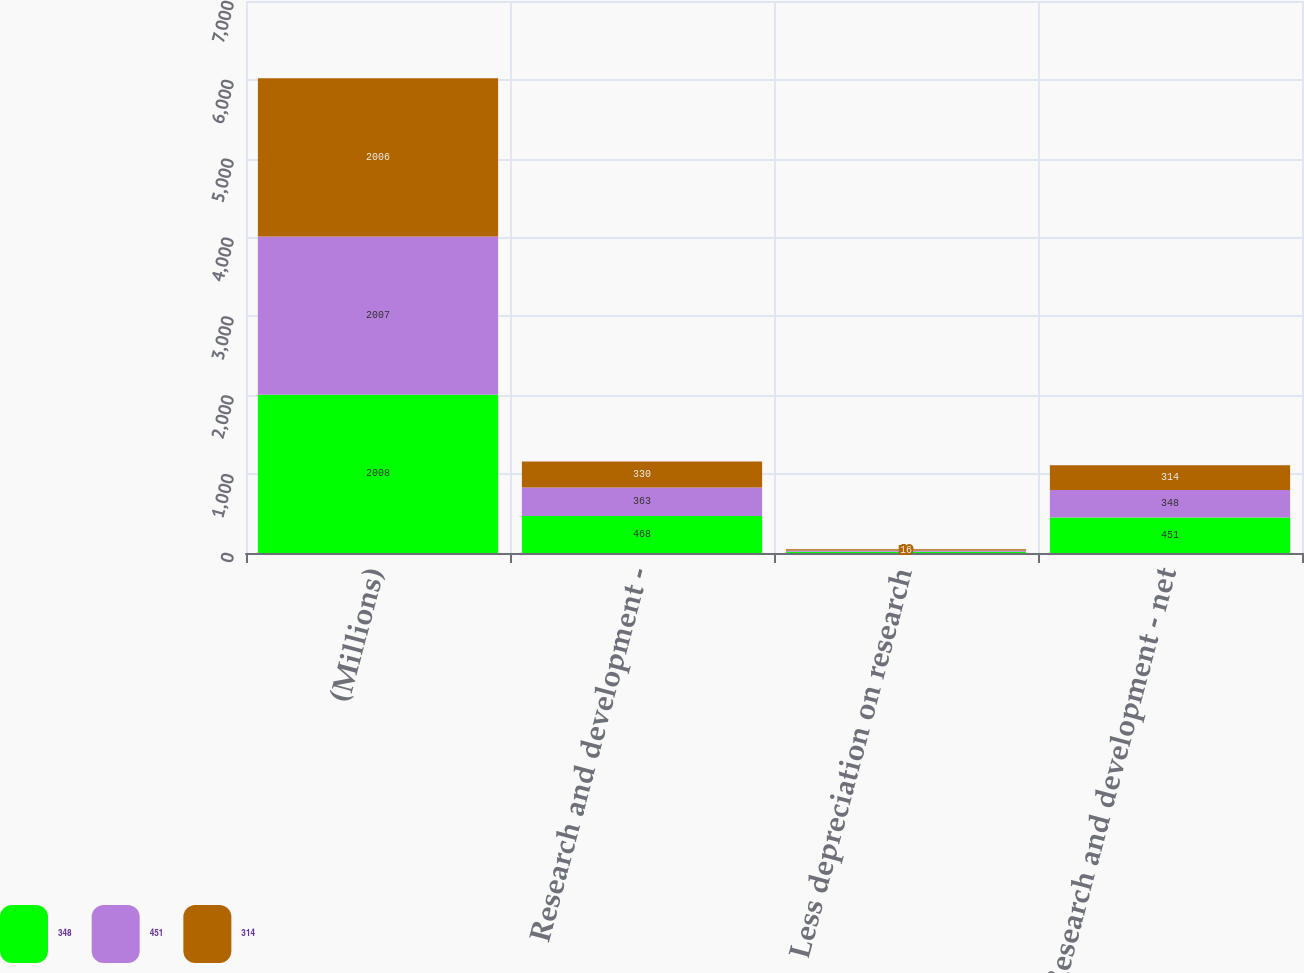<chart> <loc_0><loc_0><loc_500><loc_500><stacked_bar_chart><ecel><fcel>(Millions)<fcel>Research and development -<fcel>Less depreciation on research<fcel>Research and development - net<nl><fcel>348<fcel>2008<fcel>468<fcel>17<fcel>451<nl><fcel>451<fcel>2007<fcel>363<fcel>15<fcel>348<nl><fcel>314<fcel>2006<fcel>330<fcel>16<fcel>314<nl></chart> 